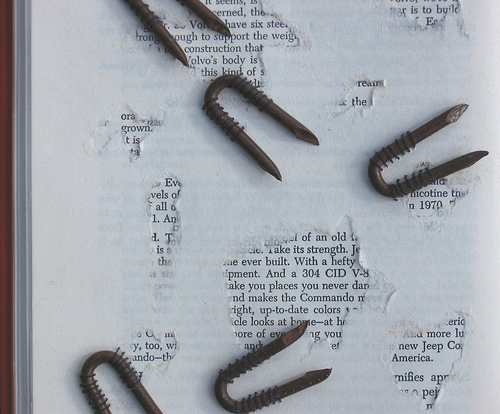<image>
Is the tool above the page? No. The tool is not positioned above the page. The vertical arrangement shows a different relationship. 